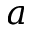Convert formula to latex. <formula><loc_0><loc_0><loc_500><loc_500>{ a }</formula> 